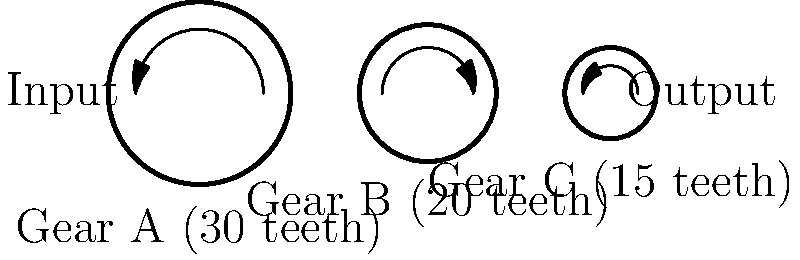As a content marketing expert, you're creating an infographic about efficiency in mechanical systems. You come across a transmission system with three gears arranged as shown in the diagram. Gear A has 30 teeth, Gear B has 20 teeth, and Gear C has 15 teeth. If Gear A rotates at 100 RPM, what is the output speed of Gear C in RPM? To solve this problem, we'll follow these steps:

1. Understand the gear ratio concept:
   The gear ratio between two meshing gears is inversely proportional to their number of teeth.

2. Calculate the gear ratio between Gear A and Gear B:
   $$ \text{Ratio A:B} = \frac{\text{Teeth of B}}{\text{Teeth of A}} = \frac{20}{30} = \frac{2}{3} $$

3. Calculate the speed of Gear B:
   $$ \text{Speed of B} = \text{Speed of A} \times \frac{\text{Teeth of A}}{\text{Teeth of B}} $$
   $$ \text{Speed of B} = 100 \text{ RPM} \times \frac{30}{20} = 150 \text{ RPM} $$

4. Calculate the gear ratio between Gear B and Gear C:
   $$ \text{Ratio B:C} = \frac{\text{Teeth of C}}{\text{Teeth of B}} = \frac{15}{20} = \frac{3}{4} $$

5. Calculate the speed of Gear C:
   $$ \text{Speed of C} = \text{Speed of B} \times \frac{\text{Teeth of B}}{\text{Teeth of C}} $$
   $$ \text{Speed of C} = 150 \text{ RPM} \times \frac{20}{15} = 200 \text{ RPM} $$

Therefore, the output speed of Gear C is 200 RPM.
Answer: 200 RPM 